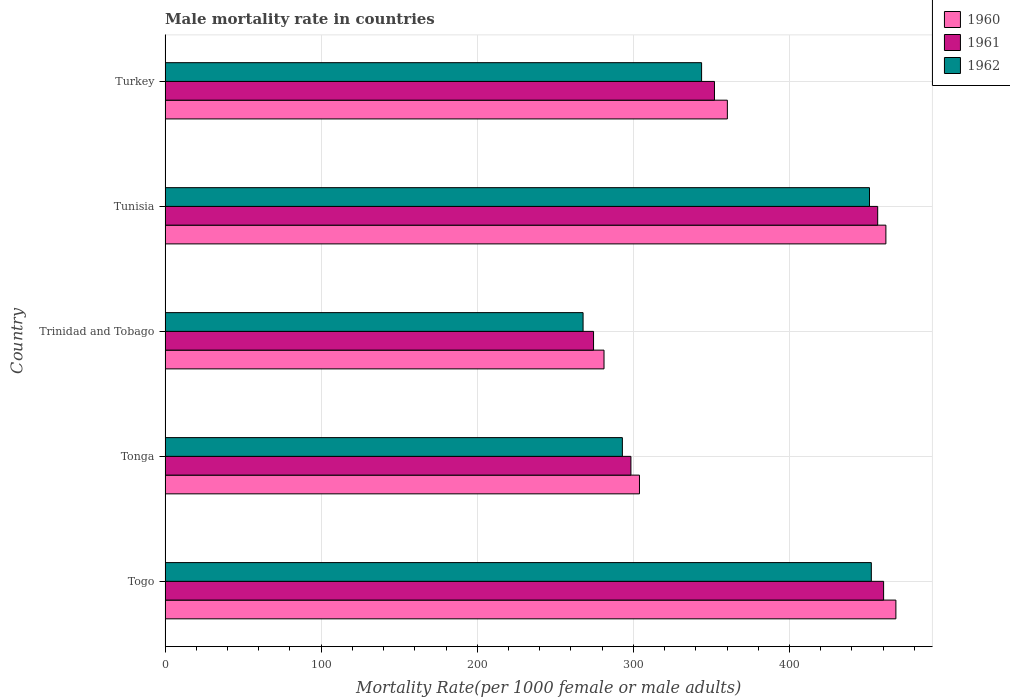Are the number of bars on each tick of the Y-axis equal?
Keep it short and to the point. Yes. How many bars are there on the 1st tick from the top?
Make the answer very short. 3. How many bars are there on the 2nd tick from the bottom?
Ensure brevity in your answer.  3. What is the label of the 3rd group of bars from the top?
Offer a terse response. Trinidad and Tobago. In how many cases, is the number of bars for a given country not equal to the number of legend labels?
Your response must be concise. 0. What is the male mortality rate in 1962 in Tunisia?
Give a very brief answer. 451.25. Across all countries, what is the maximum male mortality rate in 1960?
Offer a terse response. 468.15. Across all countries, what is the minimum male mortality rate in 1960?
Ensure brevity in your answer.  281.17. In which country was the male mortality rate in 1961 maximum?
Your response must be concise. Togo. In which country was the male mortality rate in 1961 minimum?
Provide a short and direct response. Trinidad and Tobago. What is the total male mortality rate in 1962 in the graph?
Your answer should be compact. 1808.04. What is the difference between the male mortality rate in 1960 in Togo and that in Tonga?
Keep it short and to the point. 164.27. What is the difference between the male mortality rate in 1961 in Tonga and the male mortality rate in 1960 in Togo?
Offer a very short reply. -169.74. What is the average male mortality rate in 1961 per country?
Your answer should be very brief. 368.32. What is the difference between the male mortality rate in 1962 and male mortality rate in 1961 in Tunisia?
Keep it short and to the point. -5.25. What is the ratio of the male mortality rate in 1961 in Trinidad and Tobago to that in Tunisia?
Provide a short and direct response. 0.6. Is the male mortality rate in 1961 in Togo less than that in Turkey?
Provide a short and direct response. No. What is the difference between the highest and the second highest male mortality rate in 1961?
Ensure brevity in your answer.  3.79. What is the difference between the highest and the lowest male mortality rate in 1962?
Make the answer very short. 184.66. Is the sum of the male mortality rate in 1960 in Togo and Tunisia greater than the maximum male mortality rate in 1962 across all countries?
Keep it short and to the point. Yes. What does the 3rd bar from the bottom in Tonga represents?
Make the answer very short. 1962. Are all the bars in the graph horizontal?
Keep it short and to the point. Yes. How many countries are there in the graph?
Your answer should be very brief. 5. Are the values on the major ticks of X-axis written in scientific E-notation?
Provide a short and direct response. No. Does the graph contain grids?
Make the answer very short. Yes. How are the legend labels stacked?
Keep it short and to the point. Vertical. What is the title of the graph?
Your answer should be very brief. Male mortality rate in countries. What is the label or title of the X-axis?
Your answer should be very brief. Mortality Rate(per 1000 female or male adults). What is the label or title of the Y-axis?
Your answer should be compact. Country. What is the Mortality Rate(per 1000 female or male adults) in 1960 in Togo?
Offer a terse response. 468.15. What is the Mortality Rate(per 1000 female or male adults) in 1961 in Togo?
Your answer should be very brief. 460.29. What is the Mortality Rate(per 1000 female or male adults) in 1962 in Togo?
Offer a terse response. 452.42. What is the Mortality Rate(per 1000 female or male adults) in 1960 in Tonga?
Ensure brevity in your answer.  303.88. What is the Mortality Rate(per 1000 female or male adults) in 1961 in Tonga?
Your answer should be compact. 298.41. What is the Mortality Rate(per 1000 female or male adults) of 1962 in Tonga?
Offer a very short reply. 292.94. What is the Mortality Rate(per 1000 female or male adults) in 1960 in Trinidad and Tobago?
Provide a short and direct response. 281.17. What is the Mortality Rate(per 1000 female or male adults) of 1961 in Trinidad and Tobago?
Give a very brief answer. 274.46. What is the Mortality Rate(per 1000 female or male adults) of 1962 in Trinidad and Tobago?
Keep it short and to the point. 267.76. What is the Mortality Rate(per 1000 female or male adults) of 1960 in Tunisia?
Give a very brief answer. 461.74. What is the Mortality Rate(per 1000 female or male adults) in 1961 in Tunisia?
Keep it short and to the point. 456.5. What is the Mortality Rate(per 1000 female or male adults) in 1962 in Tunisia?
Offer a terse response. 451.25. What is the Mortality Rate(per 1000 female or male adults) of 1960 in Turkey?
Keep it short and to the point. 360.19. What is the Mortality Rate(per 1000 female or male adults) in 1961 in Turkey?
Your answer should be very brief. 351.93. What is the Mortality Rate(per 1000 female or male adults) of 1962 in Turkey?
Provide a short and direct response. 343.68. Across all countries, what is the maximum Mortality Rate(per 1000 female or male adults) in 1960?
Your response must be concise. 468.15. Across all countries, what is the maximum Mortality Rate(per 1000 female or male adults) in 1961?
Your answer should be compact. 460.29. Across all countries, what is the maximum Mortality Rate(per 1000 female or male adults) of 1962?
Offer a very short reply. 452.42. Across all countries, what is the minimum Mortality Rate(per 1000 female or male adults) of 1960?
Provide a short and direct response. 281.17. Across all countries, what is the minimum Mortality Rate(per 1000 female or male adults) in 1961?
Your answer should be very brief. 274.46. Across all countries, what is the minimum Mortality Rate(per 1000 female or male adults) of 1962?
Make the answer very short. 267.76. What is the total Mortality Rate(per 1000 female or male adults) of 1960 in the graph?
Ensure brevity in your answer.  1875.13. What is the total Mortality Rate(per 1000 female or male adults) of 1961 in the graph?
Make the answer very short. 1841.59. What is the total Mortality Rate(per 1000 female or male adults) in 1962 in the graph?
Ensure brevity in your answer.  1808.04. What is the difference between the Mortality Rate(per 1000 female or male adults) in 1960 in Togo and that in Tonga?
Provide a succinct answer. 164.27. What is the difference between the Mortality Rate(per 1000 female or male adults) in 1961 in Togo and that in Tonga?
Provide a succinct answer. 161.88. What is the difference between the Mortality Rate(per 1000 female or male adults) in 1962 in Togo and that in Tonga?
Ensure brevity in your answer.  159.48. What is the difference between the Mortality Rate(per 1000 female or male adults) of 1960 in Togo and that in Trinidad and Tobago?
Ensure brevity in your answer.  186.98. What is the difference between the Mortality Rate(per 1000 female or male adults) in 1961 in Togo and that in Trinidad and Tobago?
Your answer should be very brief. 185.82. What is the difference between the Mortality Rate(per 1000 female or male adults) of 1962 in Togo and that in Trinidad and Tobago?
Provide a succinct answer. 184.66. What is the difference between the Mortality Rate(per 1000 female or male adults) of 1960 in Togo and that in Tunisia?
Provide a succinct answer. 6.41. What is the difference between the Mortality Rate(per 1000 female or male adults) in 1961 in Togo and that in Tunisia?
Provide a short and direct response. 3.79. What is the difference between the Mortality Rate(per 1000 female or male adults) of 1962 in Togo and that in Tunisia?
Ensure brevity in your answer.  1.17. What is the difference between the Mortality Rate(per 1000 female or male adults) in 1960 in Togo and that in Turkey?
Provide a short and direct response. 107.97. What is the difference between the Mortality Rate(per 1000 female or male adults) in 1961 in Togo and that in Turkey?
Provide a short and direct response. 108.35. What is the difference between the Mortality Rate(per 1000 female or male adults) of 1962 in Togo and that in Turkey?
Give a very brief answer. 108.74. What is the difference between the Mortality Rate(per 1000 female or male adults) in 1960 in Tonga and that in Trinidad and Tobago?
Provide a short and direct response. 22.71. What is the difference between the Mortality Rate(per 1000 female or male adults) in 1961 in Tonga and that in Trinidad and Tobago?
Offer a very short reply. 23.95. What is the difference between the Mortality Rate(per 1000 female or male adults) in 1962 in Tonga and that in Trinidad and Tobago?
Provide a short and direct response. 25.18. What is the difference between the Mortality Rate(per 1000 female or male adults) in 1960 in Tonga and that in Tunisia?
Give a very brief answer. -157.86. What is the difference between the Mortality Rate(per 1000 female or male adults) of 1961 in Tonga and that in Tunisia?
Offer a terse response. -158.09. What is the difference between the Mortality Rate(per 1000 female or male adults) of 1962 in Tonga and that in Tunisia?
Your answer should be compact. -158.31. What is the difference between the Mortality Rate(per 1000 female or male adults) of 1960 in Tonga and that in Turkey?
Provide a succinct answer. -56.3. What is the difference between the Mortality Rate(per 1000 female or male adults) of 1961 in Tonga and that in Turkey?
Your response must be concise. -53.52. What is the difference between the Mortality Rate(per 1000 female or male adults) in 1962 in Tonga and that in Turkey?
Offer a very short reply. -50.74. What is the difference between the Mortality Rate(per 1000 female or male adults) in 1960 in Trinidad and Tobago and that in Tunisia?
Your answer should be very brief. -180.57. What is the difference between the Mortality Rate(per 1000 female or male adults) of 1961 in Trinidad and Tobago and that in Tunisia?
Give a very brief answer. -182.03. What is the difference between the Mortality Rate(per 1000 female or male adults) of 1962 in Trinidad and Tobago and that in Tunisia?
Provide a succinct answer. -183.49. What is the difference between the Mortality Rate(per 1000 female or male adults) in 1960 in Trinidad and Tobago and that in Turkey?
Your answer should be very brief. -79.01. What is the difference between the Mortality Rate(per 1000 female or male adults) of 1961 in Trinidad and Tobago and that in Turkey?
Offer a terse response. -77.47. What is the difference between the Mortality Rate(per 1000 female or male adults) of 1962 in Trinidad and Tobago and that in Turkey?
Your answer should be very brief. -75.92. What is the difference between the Mortality Rate(per 1000 female or male adults) of 1960 in Tunisia and that in Turkey?
Provide a succinct answer. 101.56. What is the difference between the Mortality Rate(per 1000 female or male adults) in 1961 in Tunisia and that in Turkey?
Provide a succinct answer. 104.56. What is the difference between the Mortality Rate(per 1000 female or male adults) of 1962 in Tunisia and that in Turkey?
Your answer should be very brief. 107.57. What is the difference between the Mortality Rate(per 1000 female or male adults) of 1960 in Togo and the Mortality Rate(per 1000 female or male adults) of 1961 in Tonga?
Your answer should be very brief. 169.74. What is the difference between the Mortality Rate(per 1000 female or male adults) in 1960 in Togo and the Mortality Rate(per 1000 female or male adults) in 1962 in Tonga?
Keep it short and to the point. 175.21. What is the difference between the Mortality Rate(per 1000 female or male adults) of 1961 in Togo and the Mortality Rate(per 1000 female or male adults) of 1962 in Tonga?
Your answer should be very brief. 167.35. What is the difference between the Mortality Rate(per 1000 female or male adults) of 1960 in Togo and the Mortality Rate(per 1000 female or male adults) of 1961 in Trinidad and Tobago?
Your response must be concise. 193.69. What is the difference between the Mortality Rate(per 1000 female or male adults) of 1960 in Togo and the Mortality Rate(per 1000 female or male adults) of 1962 in Trinidad and Tobago?
Keep it short and to the point. 200.39. What is the difference between the Mortality Rate(per 1000 female or male adults) in 1961 in Togo and the Mortality Rate(per 1000 female or male adults) in 1962 in Trinidad and Tobago?
Give a very brief answer. 192.53. What is the difference between the Mortality Rate(per 1000 female or male adults) in 1960 in Togo and the Mortality Rate(per 1000 female or male adults) in 1961 in Tunisia?
Give a very brief answer. 11.66. What is the difference between the Mortality Rate(per 1000 female or male adults) in 1960 in Togo and the Mortality Rate(per 1000 female or male adults) in 1962 in Tunisia?
Offer a very short reply. 16.9. What is the difference between the Mortality Rate(per 1000 female or male adults) in 1961 in Togo and the Mortality Rate(per 1000 female or male adults) in 1962 in Tunisia?
Provide a succinct answer. 9.04. What is the difference between the Mortality Rate(per 1000 female or male adults) in 1960 in Togo and the Mortality Rate(per 1000 female or male adults) in 1961 in Turkey?
Give a very brief answer. 116.22. What is the difference between the Mortality Rate(per 1000 female or male adults) in 1960 in Togo and the Mortality Rate(per 1000 female or male adults) in 1962 in Turkey?
Ensure brevity in your answer.  124.47. What is the difference between the Mortality Rate(per 1000 female or male adults) of 1961 in Togo and the Mortality Rate(per 1000 female or male adults) of 1962 in Turkey?
Ensure brevity in your answer.  116.61. What is the difference between the Mortality Rate(per 1000 female or male adults) of 1960 in Tonga and the Mortality Rate(per 1000 female or male adults) of 1961 in Trinidad and Tobago?
Provide a succinct answer. 29.42. What is the difference between the Mortality Rate(per 1000 female or male adults) in 1960 in Tonga and the Mortality Rate(per 1000 female or male adults) in 1962 in Trinidad and Tobago?
Your answer should be compact. 36.12. What is the difference between the Mortality Rate(per 1000 female or male adults) in 1961 in Tonga and the Mortality Rate(per 1000 female or male adults) in 1962 in Trinidad and Tobago?
Offer a terse response. 30.65. What is the difference between the Mortality Rate(per 1000 female or male adults) of 1960 in Tonga and the Mortality Rate(per 1000 female or male adults) of 1961 in Tunisia?
Give a very brief answer. -152.61. What is the difference between the Mortality Rate(per 1000 female or male adults) of 1960 in Tonga and the Mortality Rate(per 1000 female or male adults) of 1962 in Tunisia?
Ensure brevity in your answer.  -147.37. What is the difference between the Mortality Rate(per 1000 female or male adults) in 1961 in Tonga and the Mortality Rate(per 1000 female or male adults) in 1962 in Tunisia?
Offer a terse response. -152.84. What is the difference between the Mortality Rate(per 1000 female or male adults) in 1960 in Tonga and the Mortality Rate(per 1000 female or male adults) in 1961 in Turkey?
Give a very brief answer. -48.05. What is the difference between the Mortality Rate(per 1000 female or male adults) in 1960 in Tonga and the Mortality Rate(per 1000 female or male adults) in 1962 in Turkey?
Your answer should be compact. -39.8. What is the difference between the Mortality Rate(per 1000 female or male adults) of 1961 in Tonga and the Mortality Rate(per 1000 female or male adults) of 1962 in Turkey?
Ensure brevity in your answer.  -45.27. What is the difference between the Mortality Rate(per 1000 female or male adults) of 1960 in Trinidad and Tobago and the Mortality Rate(per 1000 female or male adults) of 1961 in Tunisia?
Provide a succinct answer. -175.32. What is the difference between the Mortality Rate(per 1000 female or male adults) of 1960 in Trinidad and Tobago and the Mortality Rate(per 1000 female or male adults) of 1962 in Tunisia?
Offer a very short reply. -170.08. What is the difference between the Mortality Rate(per 1000 female or male adults) in 1961 in Trinidad and Tobago and the Mortality Rate(per 1000 female or male adults) in 1962 in Tunisia?
Offer a very short reply. -176.78. What is the difference between the Mortality Rate(per 1000 female or male adults) of 1960 in Trinidad and Tobago and the Mortality Rate(per 1000 female or male adults) of 1961 in Turkey?
Give a very brief answer. -70.76. What is the difference between the Mortality Rate(per 1000 female or male adults) in 1960 in Trinidad and Tobago and the Mortality Rate(per 1000 female or male adults) in 1962 in Turkey?
Your answer should be very brief. -62.51. What is the difference between the Mortality Rate(per 1000 female or male adults) in 1961 in Trinidad and Tobago and the Mortality Rate(per 1000 female or male adults) in 1962 in Turkey?
Your answer should be very brief. -69.22. What is the difference between the Mortality Rate(per 1000 female or male adults) in 1960 in Tunisia and the Mortality Rate(per 1000 female or male adults) in 1961 in Turkey?
Give a very brief answer. 109.81. What is the difference between the Mortality Rate(per 1000 female or male adults) in 1960 in Tunisia and the Mortality Rate(per 1000 female or male adults) in 1962 in Turkey?
Your answer should be very brief. 118.06. What is the difference between the Mortality Rate(per 1000 female or male adults) in 1961 in Tunisia and the Mortality Rate(per 1000 female or male adults) in 1962 in Turkey?
Provide a succinct answer. 112.82. What is the average Mortality Rate(per 1000 female or male adults) of 1960 per country?
Your response must be concise. 375.03. What is the average Mortality Rate(per 1000 female or male adults) in 1961 per country?
Provide a short and direct response. 368.32. What is the average Mortality Rate(per 1000 female or male adults) of 1962 per country?
Keep it short and to the point. 361.61. What is the difference between the Mortality Rate(per 1000 female or male adults) in 1960 and Mortality Rate(per 1000 female or male adults) in 1961 in Togo?
Offer a terse response. 7.87. What is the difference between the Mortality Rate(per 1000 female or male adults) of 1960 and Mortality Rate(per 1000 female or male adults) of 1962 in Togo?
Your answer should be very brief. 15.73. What is the difference between the Mortality Rate(per 1000 female or male adults) in 1961 and Mortality Rate(per 1000 female or male adults) in 1962 in Togo?
Make the answer very short. 7.87. What is the difference between the Mortality Rate(per 1000 female or male adults) in 1960 and Mortality Rate(per 1000 female or male adults) in 1961 in Tonga?
Provide a succinct answer. 5.47. What is the difference between the Mortality Rate(per 1000 female or male adults) in 1960 and Mortality Rate(per 1000 female or male adults) in 1962 in Tonga?
Provide a succinct answer. 10.94. What is the difference between the Mortality Rate(per 1000 female or male adults) of 1961 and Mortality Rate(per 1000 female or male adults) of 1962 in Tonga?
Your answer should be very brief. 5.47. What is the difference between the Mortality Rate(per 1000 female or male adults) in 1960 and Mortality Rate(per 1000 female or male adults) in 1961 in Trinidad and Tobago?
Your answer should be compact. 6.71. What is the difference between the Mortality Rate(per 1000 female or male adults) of 1960 and Mortality Rate(per 1000 female or male adults) of 1962 in Trinidad and Tobago?
Your response must be concise. 13.41. What is the difference between the Mortality Rate(per 1000 female or male adults) of 1961 and Mortality Rate(per 1000 female or male adults) of 1962 in Trinidad and Tobago?
Your answer should be compact. 6.71. What is the difference between the Mortality Rate(per 1000 female or male adults) of 1960 and Mortality Rate(per 1000 female or male adults) of 1961 in Tunisia?
Offer a terse response. 5.25. What is the difference between the Mortality Rate(per 1000 female or male adults) of 1960 and Mortality Rate(per 1000 female or male adults) of 1962 in Tunisia?
Offer a terse response. 10.49. What is the difference between the Mortality Rate(per 1000 female or male adults) of 1961 and Mortality Rate(per 1000 female or male adults) of 1962 in Tunisia?
Provide a short and direct response. 5.25. What is the difference between the Mortality Rate(per 1000 female or male adults) in 1960 and Mortality Rate(per 1000 female or male adults) in 1961 in Turkey?
Your answer should be very brief. 8.25. What is the difference between the Mortality Rate(per 1000 female or male adults) of 1960 and Mortality Rate(per 1000 female or male adults) of 1962 in Turkey?
Provide a succinct answer. 16.51. What is the difference between the Mortality Rate(per 1000 female or male adults) in 1961 and Mortality Rate(per 1000 female or male adults) in 1962 in Turkey?
Make the answer very short. 8.25. What is the ratio of the Mortality Rate(per 1000 female or male adults) of 1960 in Togo to that in Tonga?
Your answer should be compact. 1.54. What is the ratio of the Mortality Rate(per 1000 female or male adults) of 1961 in Togo to that in Tonga?
Keep it short and to the point. 1.54. What is the ratio of the Mortality Rate(per 1000 female or male adults) of 1962 in Togo to that in Tonga?
Provide a short and direct response. 1.54. What is the ratio of the Mortality Rate(per 1000 female or male adults) of 1960 in Togo to that in Trinidad and Tobago?
Provide a succinct answer. 1.67. What is the ratio of the Mortality Rate(per 1000 female or male adults) in 1961 in Togo to that in Trinidad and Tobago?
Provide a short and direct response. 1.68. What is the ratio of the Mortality Rate(per 1000 female or male adults) in 1962 in Togo to that in Trinidad and Tobago?
Make the answer very short. 1.69. What is the ratio of the Mortality Rate(per 1000 female or male adults) of 1960 in Togo to that in Tunisia?
Provide a succinct answer. 1.01. What is the ratio of the Mortality Rate(per 1000 female or male adults) in 1961 in Togo to that in Tunisia?
Offer a very short reply. 1.01. What is the ratio of the Mortality Rate(per 1000 female or male adults) of 1962 in Togo to that in Tunisia?
Provide a short and direct response. 1. What is the ratio of the Mortality Rate(per 1000 female or male adults) in 1960 in Togo to that in Turkey?
Provide a succinct answer. 1.3. What is the ratio of the Mortality Rate(per 1000 female or male adults) in 1961 in Togo to that in Turkey?
Your answer should be very brief. 1.31. What is the ratio of the Mortality Rate(per 1000 female or male adults) in 1962 in Togo to that in Turkey?
Provide a short and direct response. 1.32. What is the ratio of the Mortality Rate(per 1000 female or male adults) in 1960 in Tonga to that in Trinidad and Tobago?
Your answer should be very brief. 1.08. What is the ratio of the Mortality Rate(per 1000 female or male adults) of 1961 in Tonga to that in Trinidad and Tobago?
Provide a succinct answer. 1.09. What is the ratio of the Mortality Rate(per 1000 female or male adults) in 1962 in Tonga to that in Trinidad and Tobago?
Ensure brevity in your answer.  1.09. What is the ratio of the Mortality Rate(per 1000 female or male adults) of 1960 in Tonga to that in Tunisia?
Make the answer very short. 0.66. What is the ratio of the Mortality Rate(per 1000 female or male adults) of 1961 in Tonga to that in Tunisia?
Provide a succinct answer. 0.65. What is the ratio of the Mortality Rate(per 1000 female or male adults) of 1962 in Tonga to that in Tunisia?
Provide a short and direct response. 0.65. What is the ratio of the Mortality Rate(per 1000 female or male adults) in 1960 in Tonga to that in Turkey?
Make the answer very short. 0.84. What is the ratio of the Mortality Rate(per 1000 female or male adults) in 1961 in Tonga to that in Turkey?
Ensure brevity in your answer.  0.85. What is the ratio of the Mortality Rate(per 1000 female or male adults) of 1962 in Tonga to that in Turkey?
Your response must be concise. 0.85. What is the ratio of the Mortality Rate(per 1000 female or male adults) of 1960 in Trinidad and Tobago to that in Tunisia?
Make the answer very short. 0.61. What is the ratio of the Mortality Rate(per 1000 female or male adults) in 1961 in Trinidad and Tobago to that in Tunisia?
Offer a terse response. 0.6. What is the ratio of the Mortality Rate(per 1000 female or male adults) in 1962 in Trinidad and Tobago to that in Tunisia?
Offer a very short reply. 0.59. What is the ratio of the Mortality Rate(per 1000 female or male adults) in 1960 in Trinidad and Tobago to that in Turkey?
Your answer should be very brief. 0.78. What is the ratio of the Mortality Rate(per 1000 female or male adults) in 1961 in Trinidad and Tobago to that in Turkey?
Your answer should be compact. 0.78. What is the ratio of the Mortality Rate(per 1000 female or male adults) in 1962 in Trinidad and Tobago to that in Turkey?
Your answer should be compact. 0.78. What is the ratio of the Mortality Rate(per 1000 female or male adults) of 1960 in Tunisia to that in Turkey?
Your answer should be very brief. 1.28. What is the ratio of the Mortality Rate(per 1000 female or male adults) of 1961 in Tunisia to that in Turkey?
Ensure brevity in your answer.  1.3. What is the ratio of the Mortality Rate(per 1000 female or male adults) of 1962 in Tunisia to that in Turkey?
Provide a short and direct response. 1.31. What is the difference between the highest and the second highest Mortality Rate(per 1000 female or male adults) of 1960?
Provide a short and direct response. 6.41. What is the difference between the highest and the second highest Mortality Rate(per 1000 female or male adults) in 1961?
Your response must be concise. 3.79. What is the difference between the highest and the second highest Mortality Rate(per 1000 female or male adults) of 1962?
Provide a short and direct response. 1.17. What is the difference between the highest and the lowest Mortality Rate(per 1000 female or male adults) in 1960?
Your answer should be very brief. 186.98. What is the difference between the highest and the lowest Mortality Rate(per 1000 female or male adults) of 1961?
Your answer should be compact. 185.82. What is the difference between the highest and the lowest Mortality Rate(per 1000 female or male adults) of 1962?
Your answer should be very brief. 184.66. 